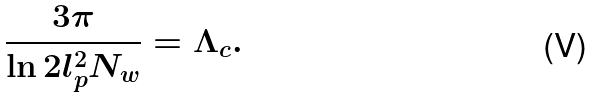Convert formula to latex. <formula><loc_0><loc_0><loc_500><loc_500>\frac { 3 \pi } { \ln 2 l _ { p } ^ { 2 } N _ { w } } = \Lambda _ { c } .</formula> 